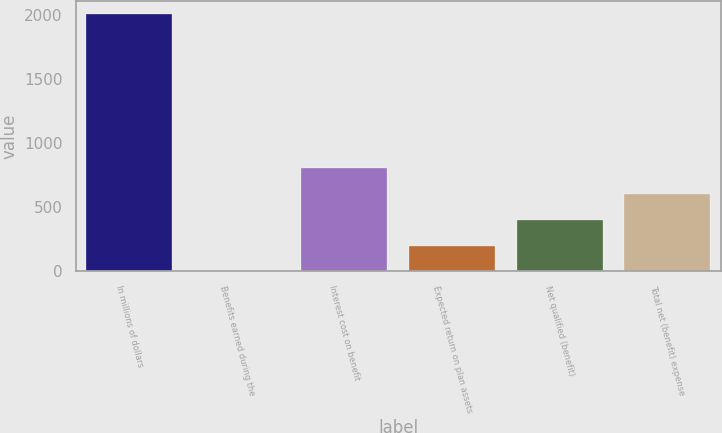Convert chart to OTSL. <chart><loc_0><loc_0><loc_500><loc_500><bar_chart><fcel>In millions of dollars<fcel>Benefits earned during the<fcel>Interest cost on benefit<fcel>Expected return on plan assets<fcel>Net qualified (benefit)<fcel>Total net (benefit) expense<nl><fcel>2009<fcel>1<fcel>804.2<fcel>201.8<fcel>402.6<fcel>603.4<nl></chart> 